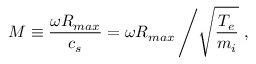<formula> <loc_0><loc_0><loc_500><loc_500>M \equiv \frac { \omega R _ { \max } } { c _ { s } } = \omega R _ { \max } \left / \sqrt { \frac { T _ { e } } { m _ { i } } } ,</formula> 